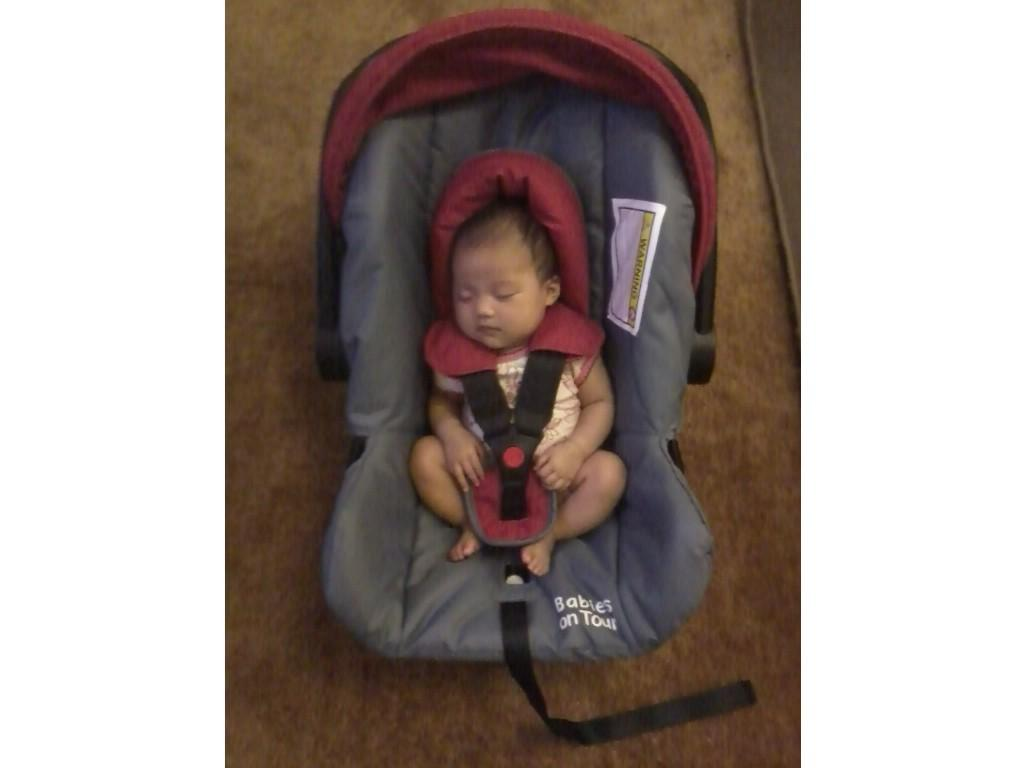What is the main subject of the image? The main subject of the image is a baby. Where is the baby located in the image? The baby is sleeping in a cart. What other object can be seen in the image? There is a belt in the image. What is the color of the belt? The belt is black in color. Where is the belt placed in the image? The belt is placed on the floor. What type of health issues does the lamp in the image have? There is no lamp present in the image; it only features a baby, a cart, and a belt. 